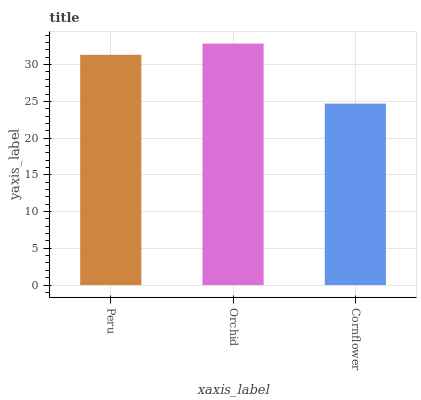Is Orchid the minimum?
Answer yes or no. No. Is Cornflower the maximum?
Answer yes or no. No. Is Orchid greater than Cornflower?
Answer yes or no. Yes. Is Cornflower less than Orchid?
Answer yes or no. Yes. Is Cornflower greater than Orchid?
Answer yes or no. No. Is Orchid less than Cornflower?
Answer yes or no. No. Is Peru the high median?
Answer yes or no. Yes. Is Peru the low median?
Answer yes or no. Yes. Is Cornflower the high median?
Answer yes or no. No. Is Orchid the low median?
Answer yes or no. No. 